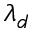Convert formula to latex. <formula><loc_0><loc_0><loc_500><loc_500>\lambda _ { d }</formula> 